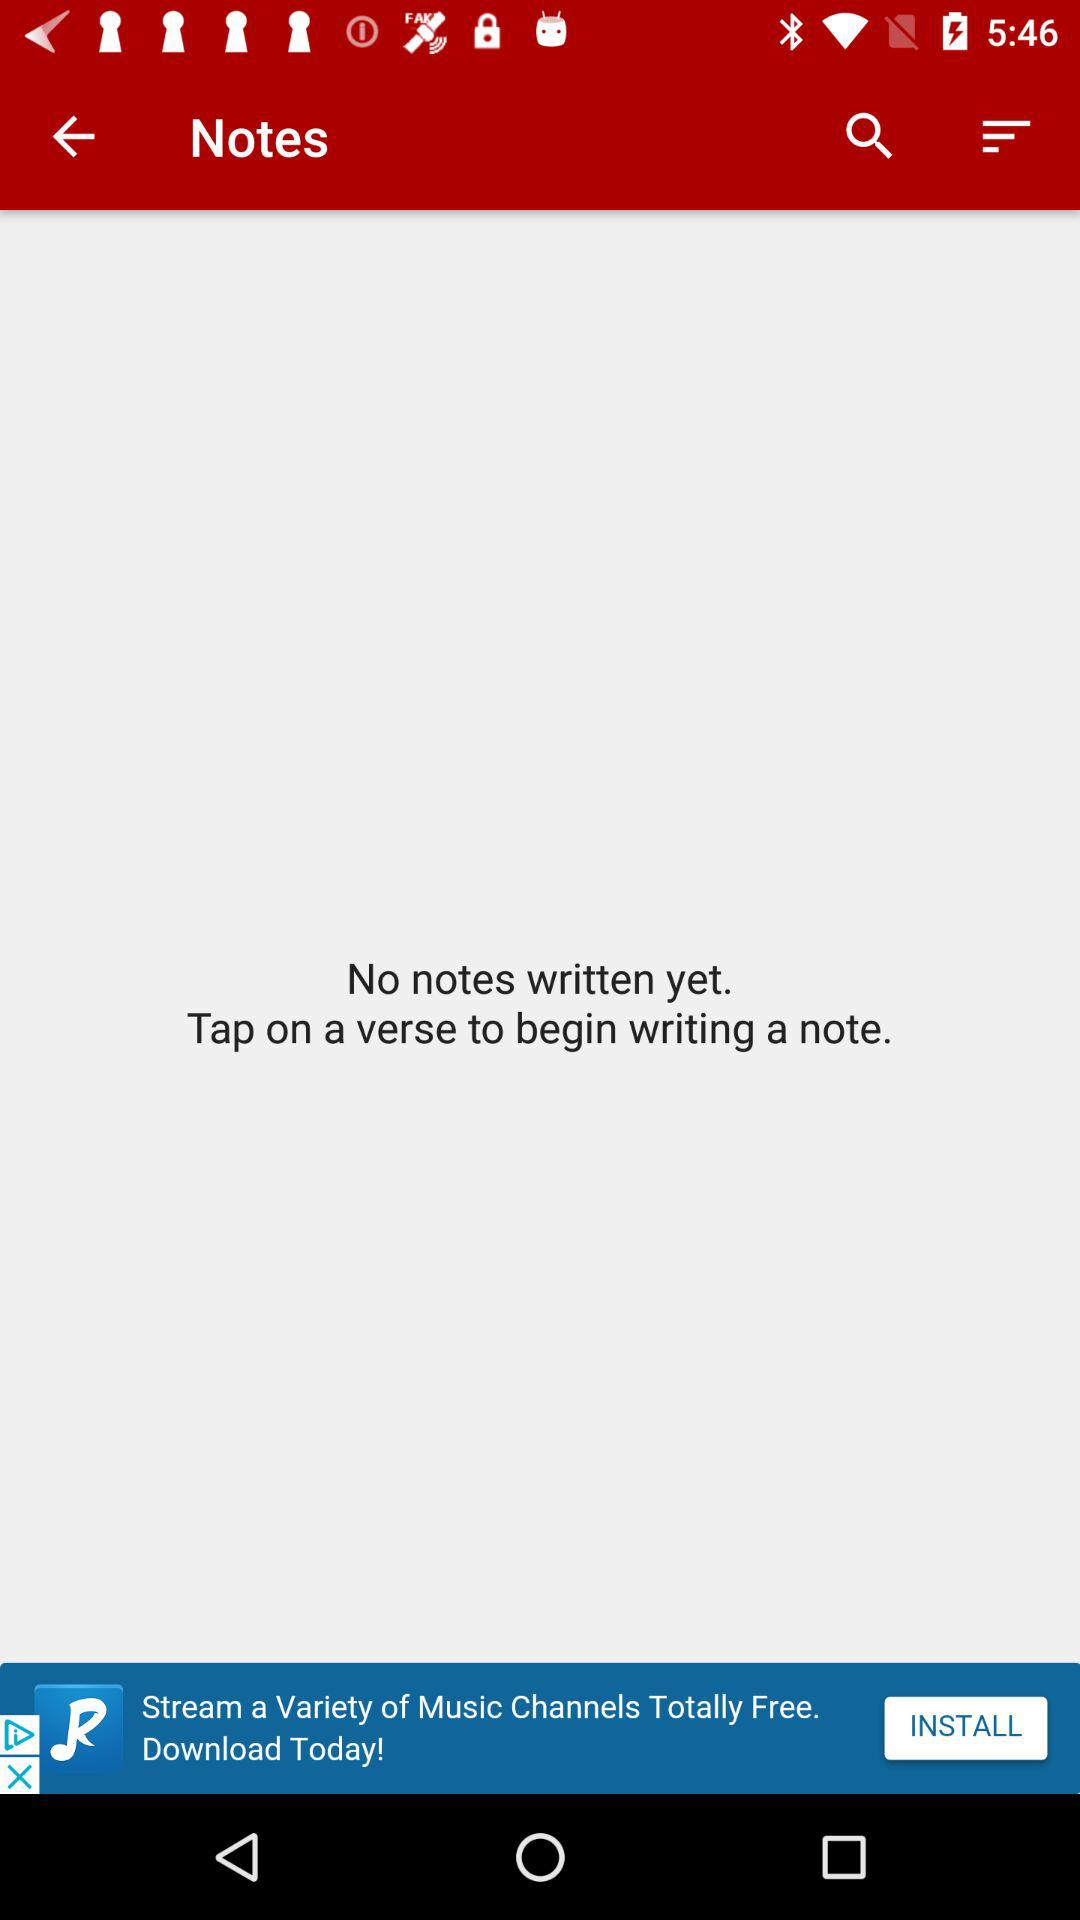How many notes have been written?
Answer the question using a single word or phrase. 0 